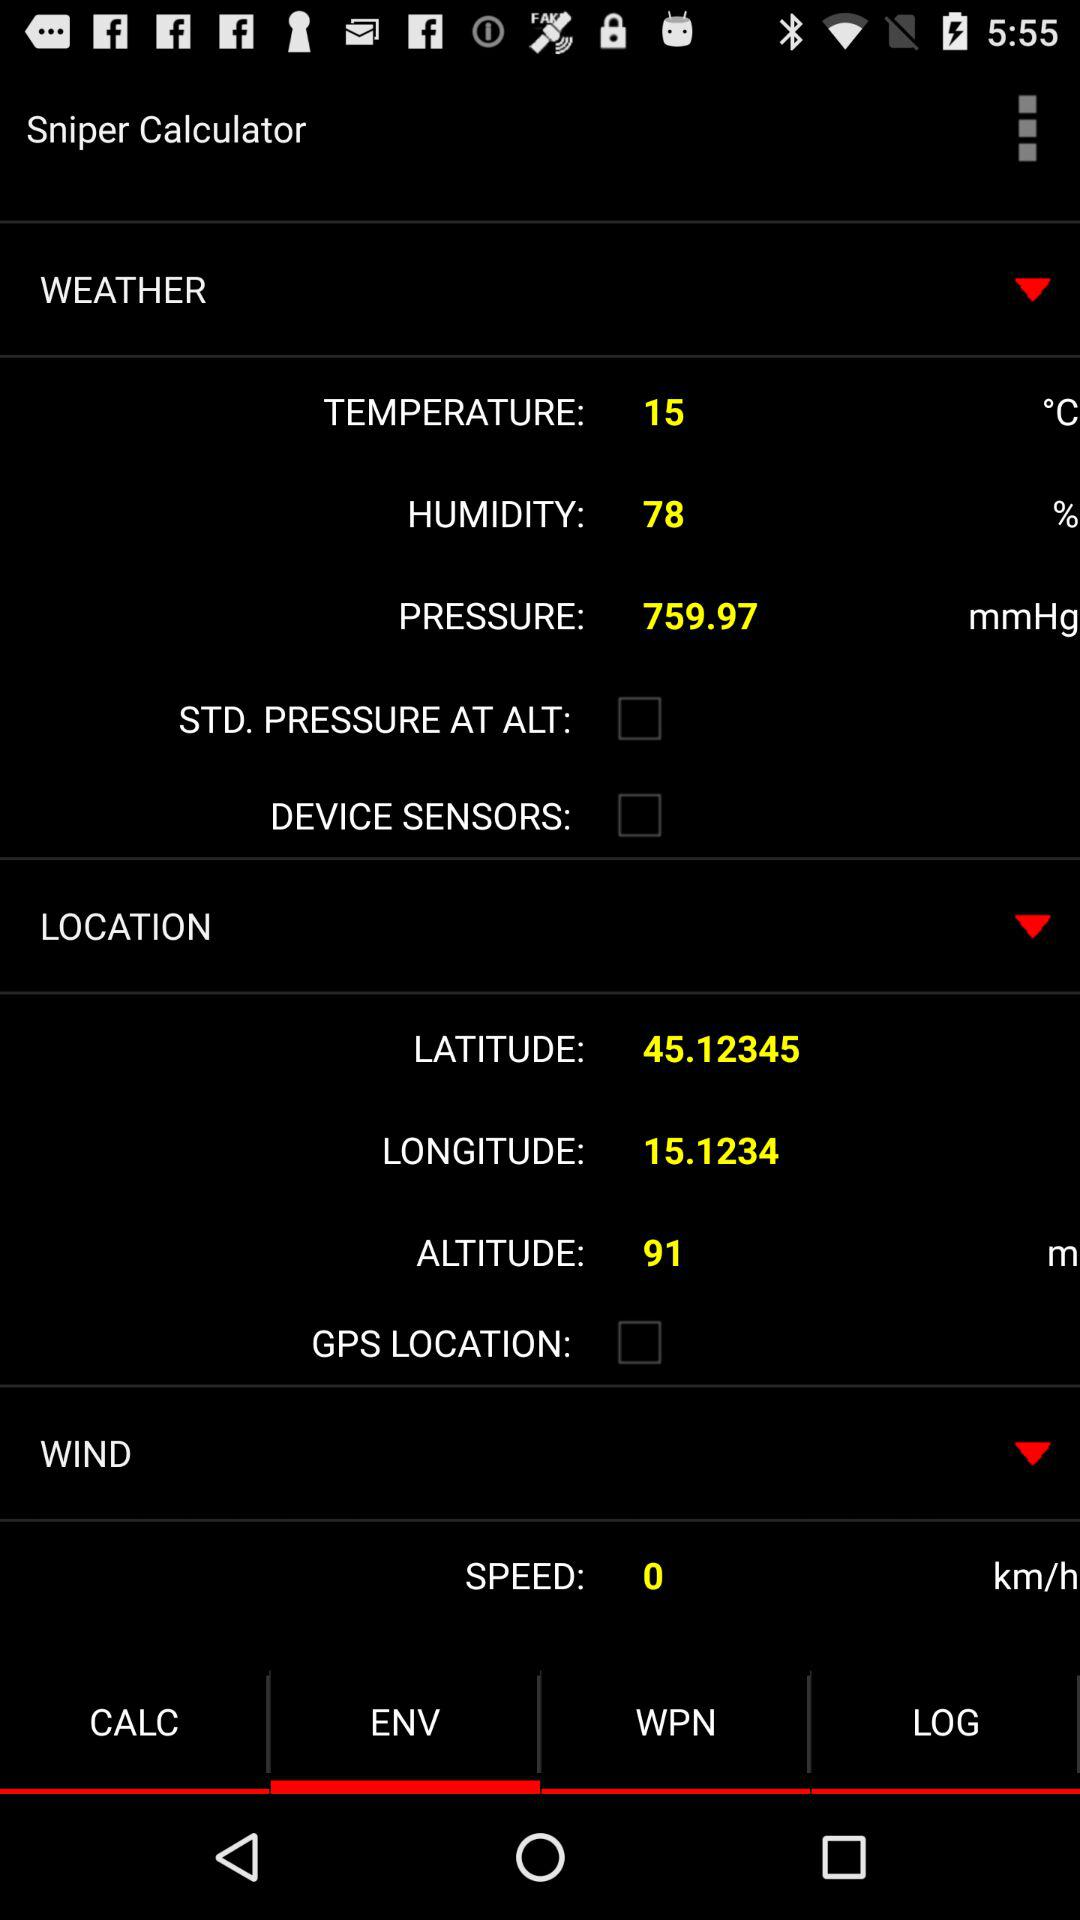What is the latitude? The latitude is 45.12345. 